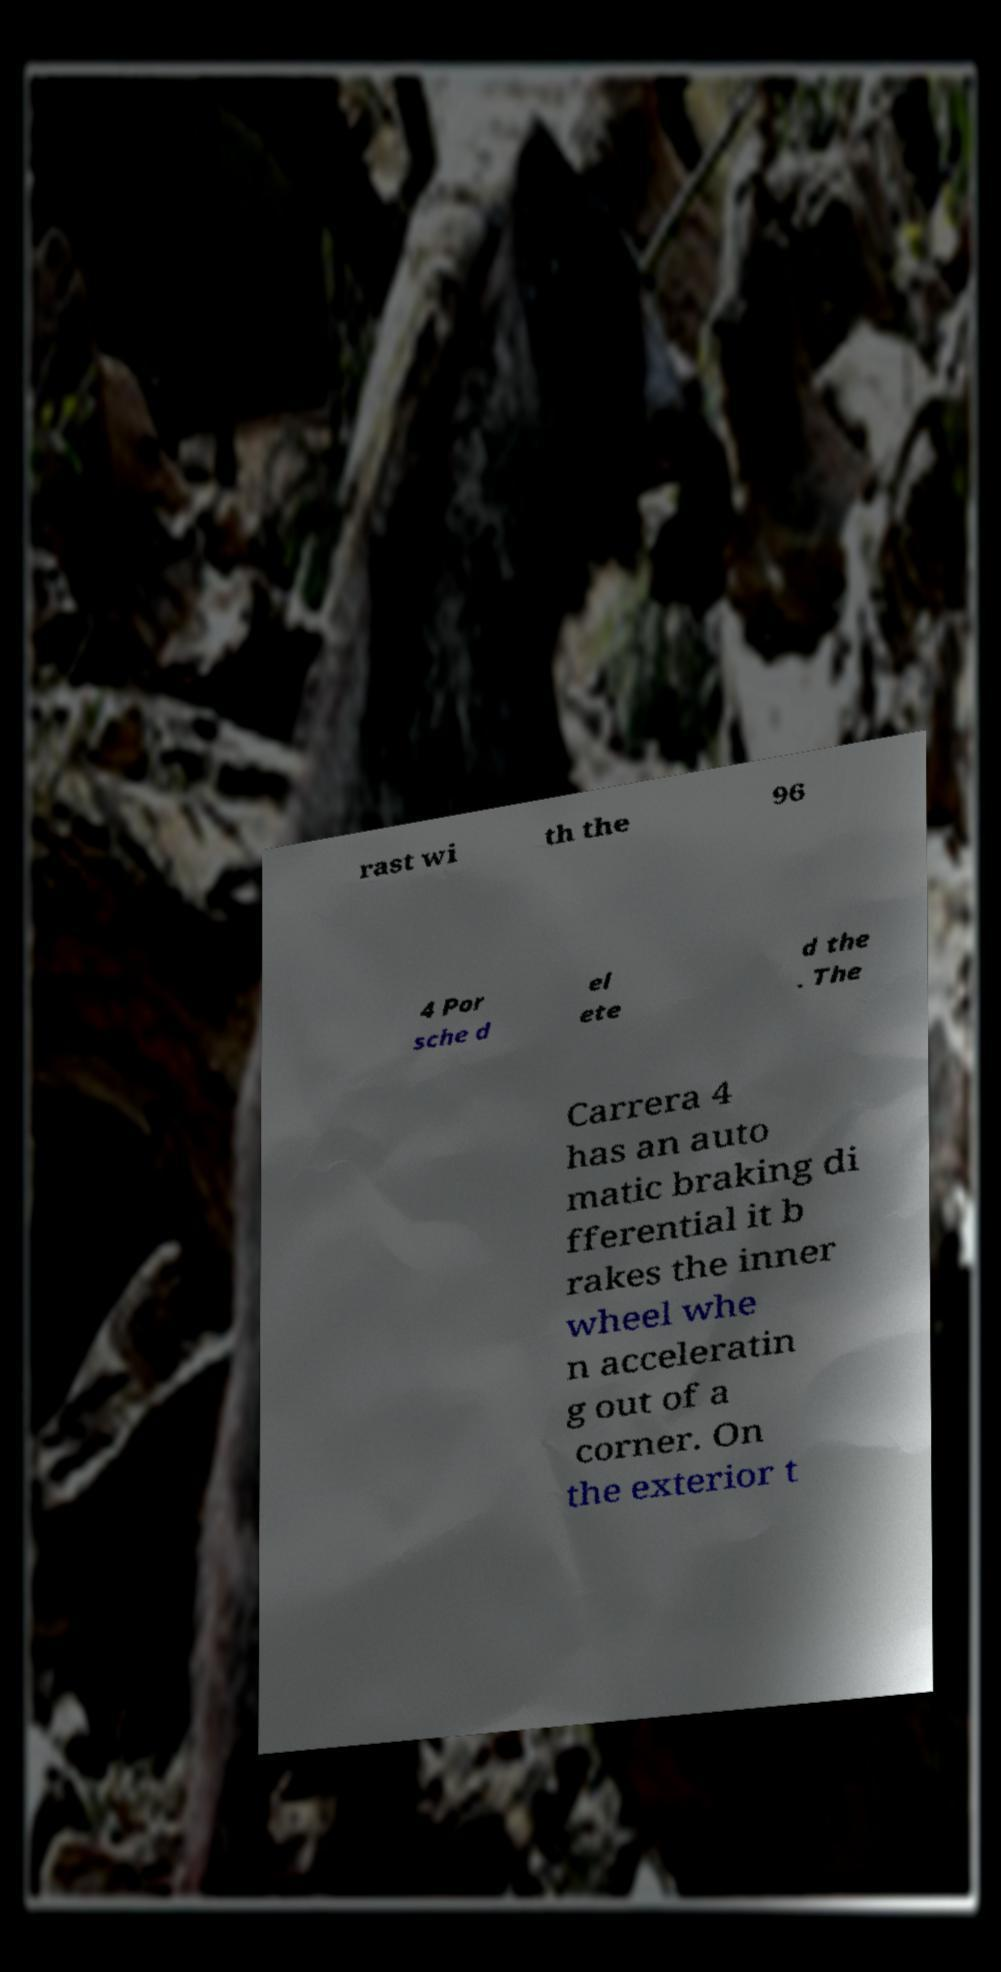What messages or text are displayed in this image? I need them in a readable, typed format. rast wi th the 96 4 Por sche d el ete d the . The Carrera 4 has an auto matic braking di fferential it b rakes the inner wheel whe n acceleratin g out of a corner. On the exterior t 